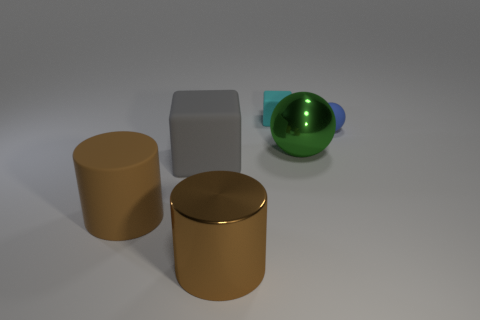The small object that is the same material as the tiny cyan cube is what shape?
Offer a very short reply. Sphere. Is there anything else that is the same color as the small cube?
Make the answer very short. No. What is the color of the matte block that is in front of the large object that is behind the big gray rubber object?
Offer a terse response. Gray. What material is the small object in front of the matte block behind the small object that is on the right side of the tiny cyan matte thing made of?
Make the answer very short. Rubber. How many brown metallic objects have the same size as the gray rubber thing?
Your answer should be compact. 1. What material is the thing that is behind the large rubber cylinder and to the left of the tiny cyan matte object?
Provide a short and direct response. Rubber. What number of brown metallic cylinders are left of the large gray thing?
Your response must be concise. 0. There is a blue object; is its shape the same as the brown object in front of the large brown rubber thing?
Offer a terse response. No. Are there any large green objects that have the same shape as the gray matte object?
Offer a terse response. No. The object to the right of the metal thing that is right of the tiny cyan object is what shape?
Keep it short and to the point. Sphere. 